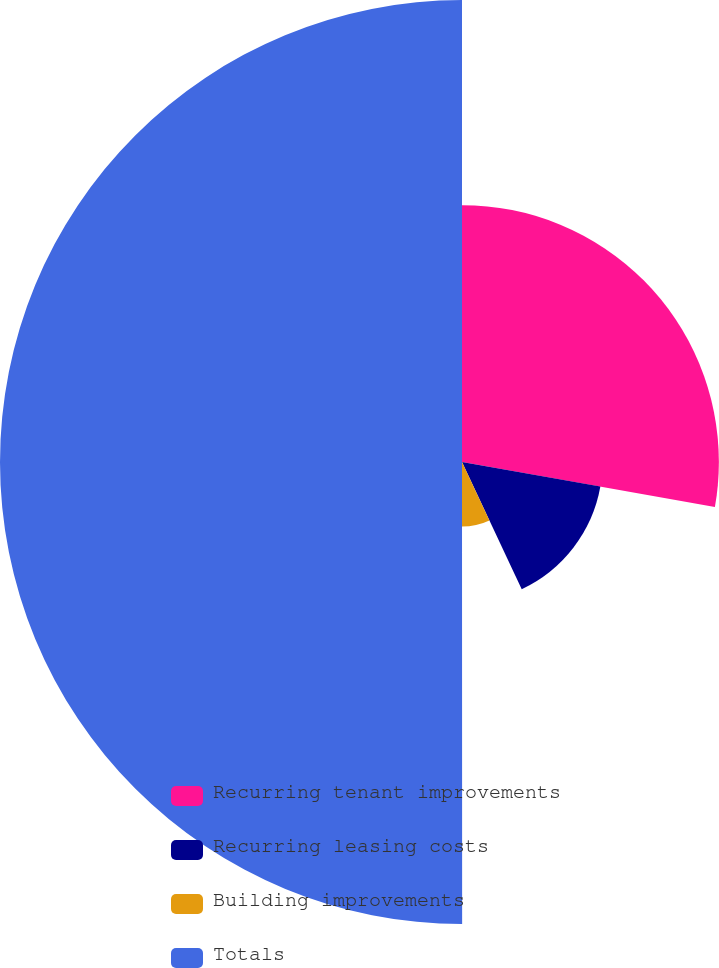Convert chart. <chart><loc_0><loc_0><loc_500><loc_500><pie_chart><fcel>Recurring tenant improvements<fcel>Recurring leasing costs<fcel>Building improvements<fcel>Totals<nl><fcel>27.8%<fcel>15.21%<fcel>6.98%<fcel>50.0%<nl></chart> 